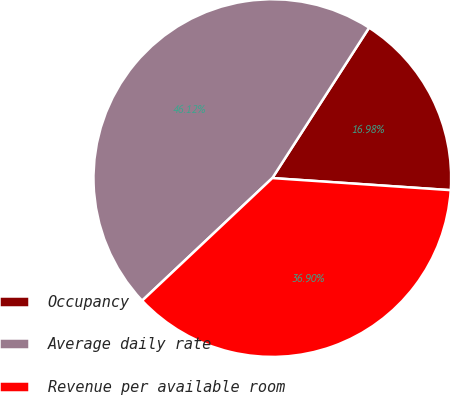<chart> <loc_0><loc_0><loc_500><loc_500><pie_chart><fcel>Occupancy<fcel>Average daily rate<fcel>Revenue per available room<nl><fcel>16.98%<fcel>46.12%<fcel>36.9%<nl></chart> 